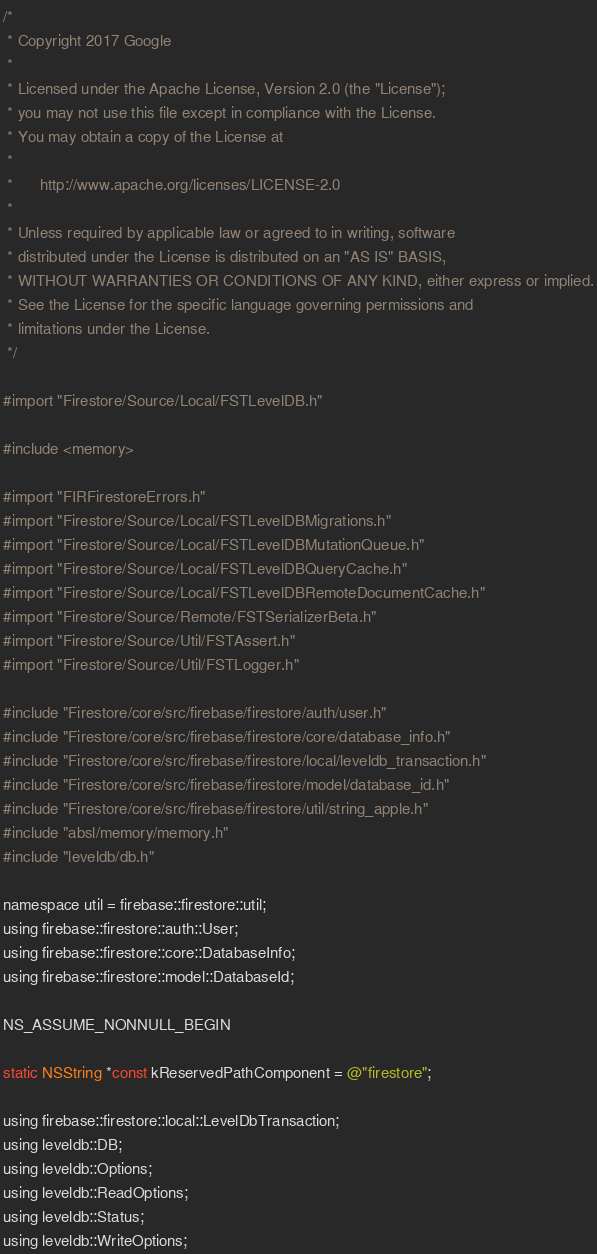Convert code to text. <code><loc_0><loc_0><loc_500><loc_500><_ObjectiveC_>/*
 * Copyright 2017 Google
 *
 * Licensed under the Apache License, Version 2.0 (the "License");
 * you may not use this file except in compliance with the License.
 * You may obtain a copy of the License at
 *
 *      http://www.apache.org/licenses/LICENSE-2.0
 *
 * Unless required by applicable law or agreed to in writing, software
 * distributed under the License is distributed on an "AS IS" BASIS,
 * WITHOUT WARRANTIES OR CONDITIONS OF ANY KIND, either express or implied.
 * See the License for the specific language governing permissions and
 * limitations under the License.
 */

#import "Firestore/Source/Local/FSTLevelDB.h"

#include <memory>

#import "FIRFirestoreErrors.h"
#import "Firestore/Source/Local/FSTLevelDBMigrations.h"
#import "Firestore/Source/Local/FSTLevelDBMutationQueue.h"
#import "Firestore/Source/Local/FSTLevelDBQueryCache.h"
#import "Firestore/Source/Local/FSTLevelDBRemoteDocumentCache.h"
#import "Firestore/Source/Remote/FSTSerializerBeta.h"
#import "Firestore/Source/Util/FSTAssert.h"
#import "Firestore/Source/Util/FSTLogger.h"

#include "Firestore/core/src/firebase/firestore/auth/user.h"
#include "Firestore/core/src/firebase/firestore/core/database_info.h"
#include "Firestore/core/src/firebase/firestore/local/leveldb_transaction.h"
#include "Firestore/core/src/firebase/firestore/model/database_id.h"
#include "Firestore/core/src/firebase/firestore/util/string_apple.h"
#include "absl/memory/memory.h"
#include "leveldb/db.h"

namespace util = firebase::firestore::util;
using firebase::firestore::auth::User;
using firebase::firestore::core::DatabaseInfo;
using firebase::firestore::model::DatabaseId;

NS_ASSUME_NONNULL_BEGIN

static NSString *const kReservedPathComponent = @"firestore";

using firebase::firestore::local::LevelDbTransaction;
using leveldb::DB;
using leveldb::Options;
using leveldb::ReadOptions;
using leveldb::Status;
using leveldb::WriteOptions;
</code> 